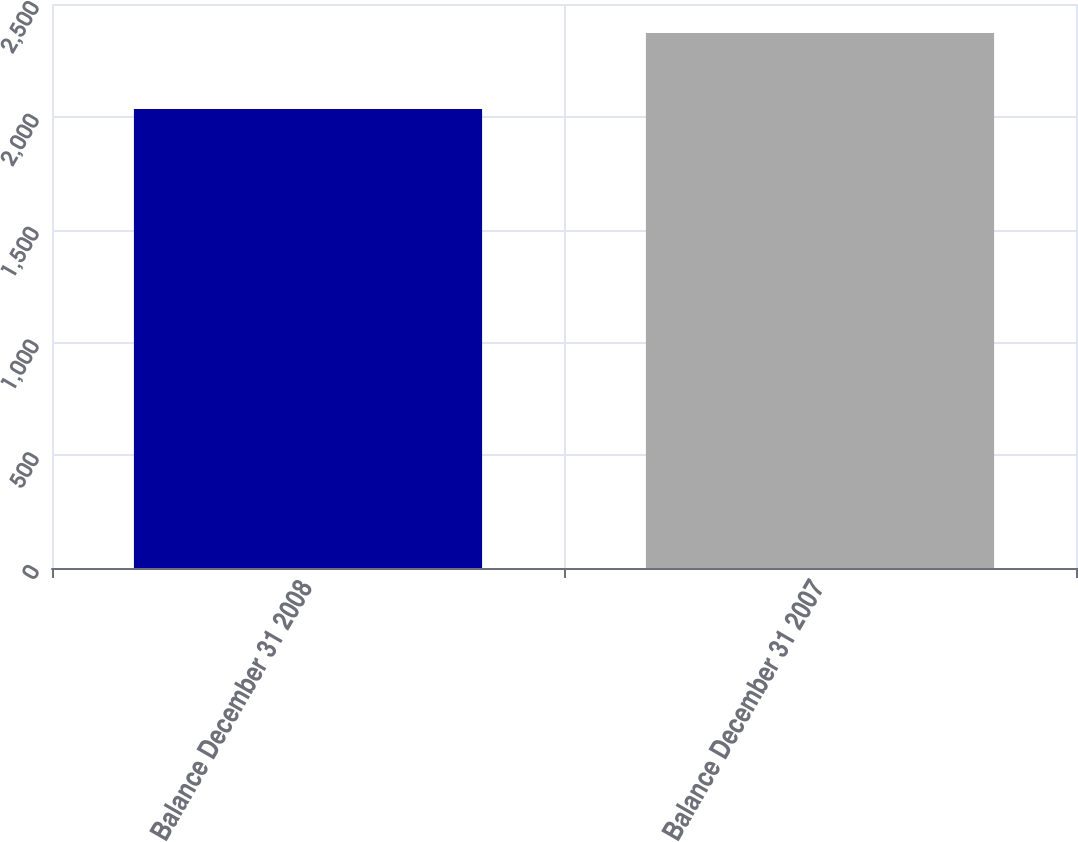<chart> <loc_0><loc_0><loc_500><loc_500><bar_chart><fcel>Balance December 31 2008<fcel>Balance December 31 2007<nl><fcel>2035<fcel>2371<nl></chart> 